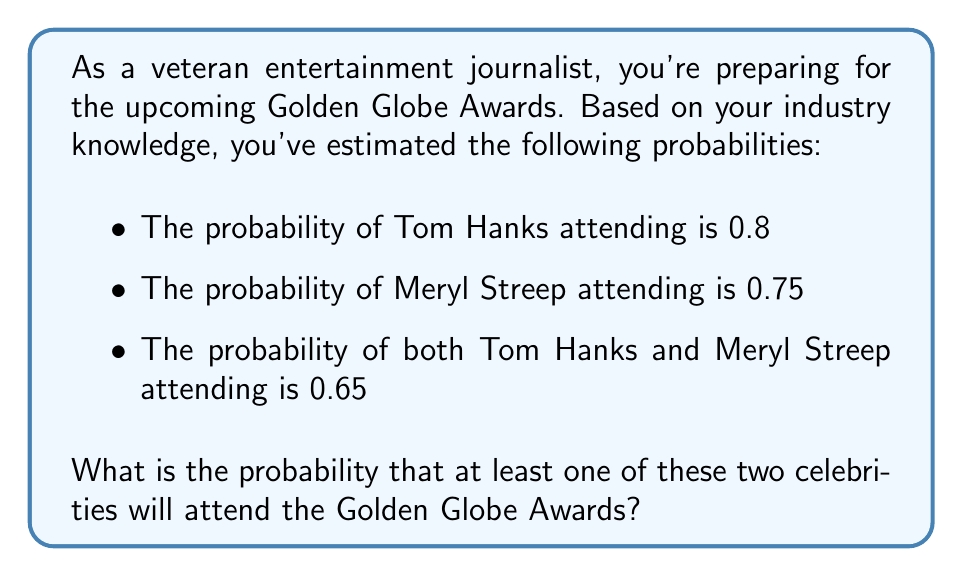Show me your answer to this math problem. To solve this problem, we'll use the concept of probability of union of events. Let's define our events:

$A$: Tom Hanks attends
$B$: Meryl Streep attends

We're given:
$P(A) = 0.8$
$P(B) = 0.75$
$P(A \cap B) = 0.65$

We want to find $P(A \cup B)$, which is the probability that at least one of them attends.

The formula for the probability of union of two events is:

$$P(A \cup B) = P(A) + P(B) - P(A \cap B)$$

This formula accounts for the overlap between the two events to avoid double-counting.

Substituting our known values:

$$P(A \cup B) = 0.8 + 0.75 - 0.65$$

$$P(A \cup B) = 1.55 - 0.65$$

$$P(A \cup B) = 0.9$$

Therefore, the probability that at least one of these two celebrities will attend the Golden Globe Awards is 0.9 or 90%.
Answer: 0.9 or 90% 